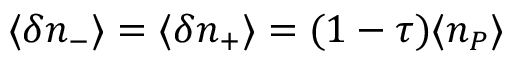<formula> <loc_0><loc_0><loc_500><loc_500>\langle \delta n _ { - } \rangle = \langle \delta n _ { + } \rangle = ( 1 - \tau ) \langle n _ { P } \rangle</formula> 